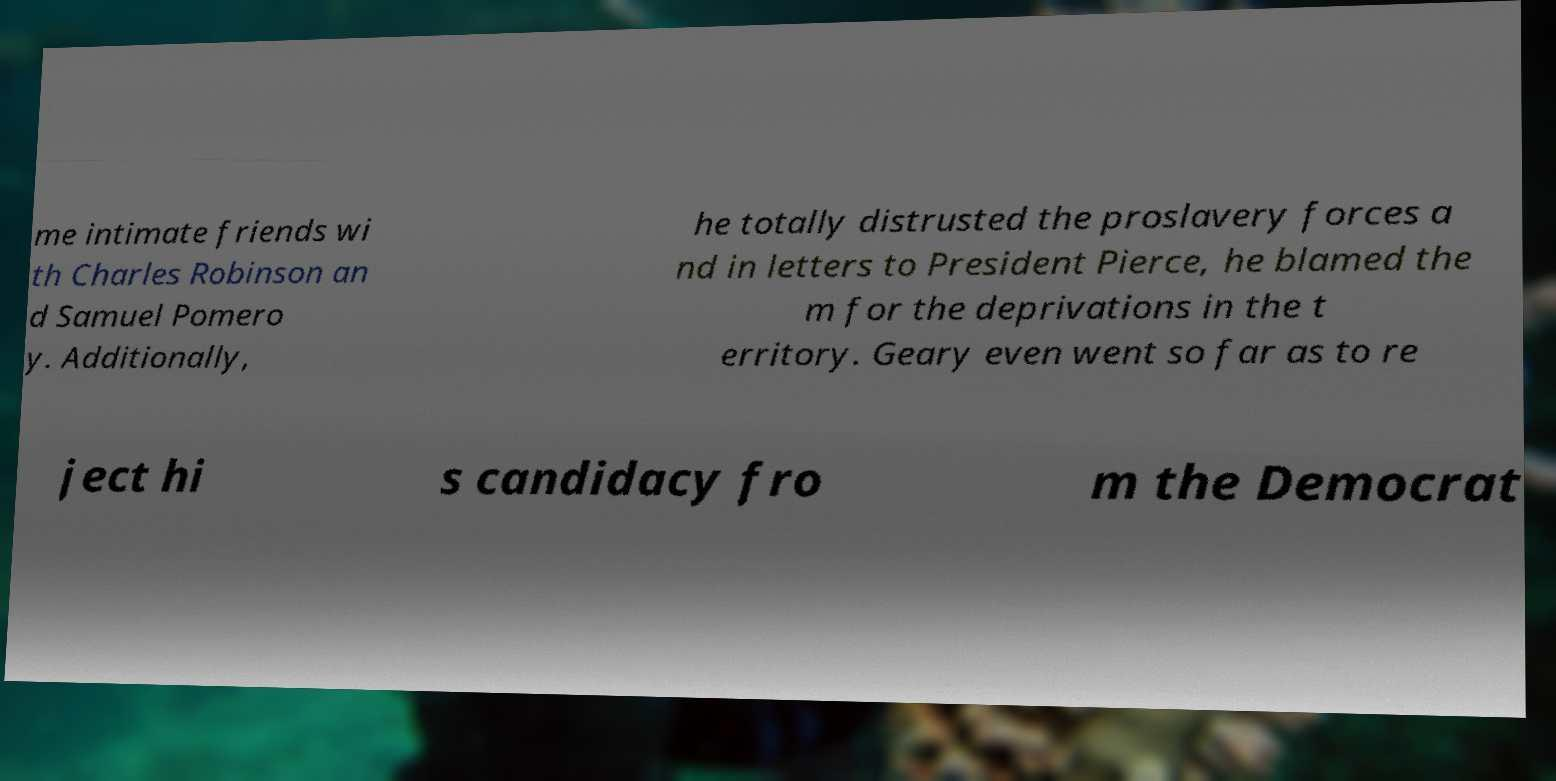Can you read and provide the text displayed in the image?This photo seems to have some interesting text. Can you extract and type it out for me? me intimate friends wi th Charles Robinson an d Samuel Pomero y. Additionally, he totally distrusted the proslavery forces a nd in letters to President Pierce, he blamed the m for the deprivations in the t erritory. Geary even went so far as to re ject hi s candidacy fro m the Democrat 